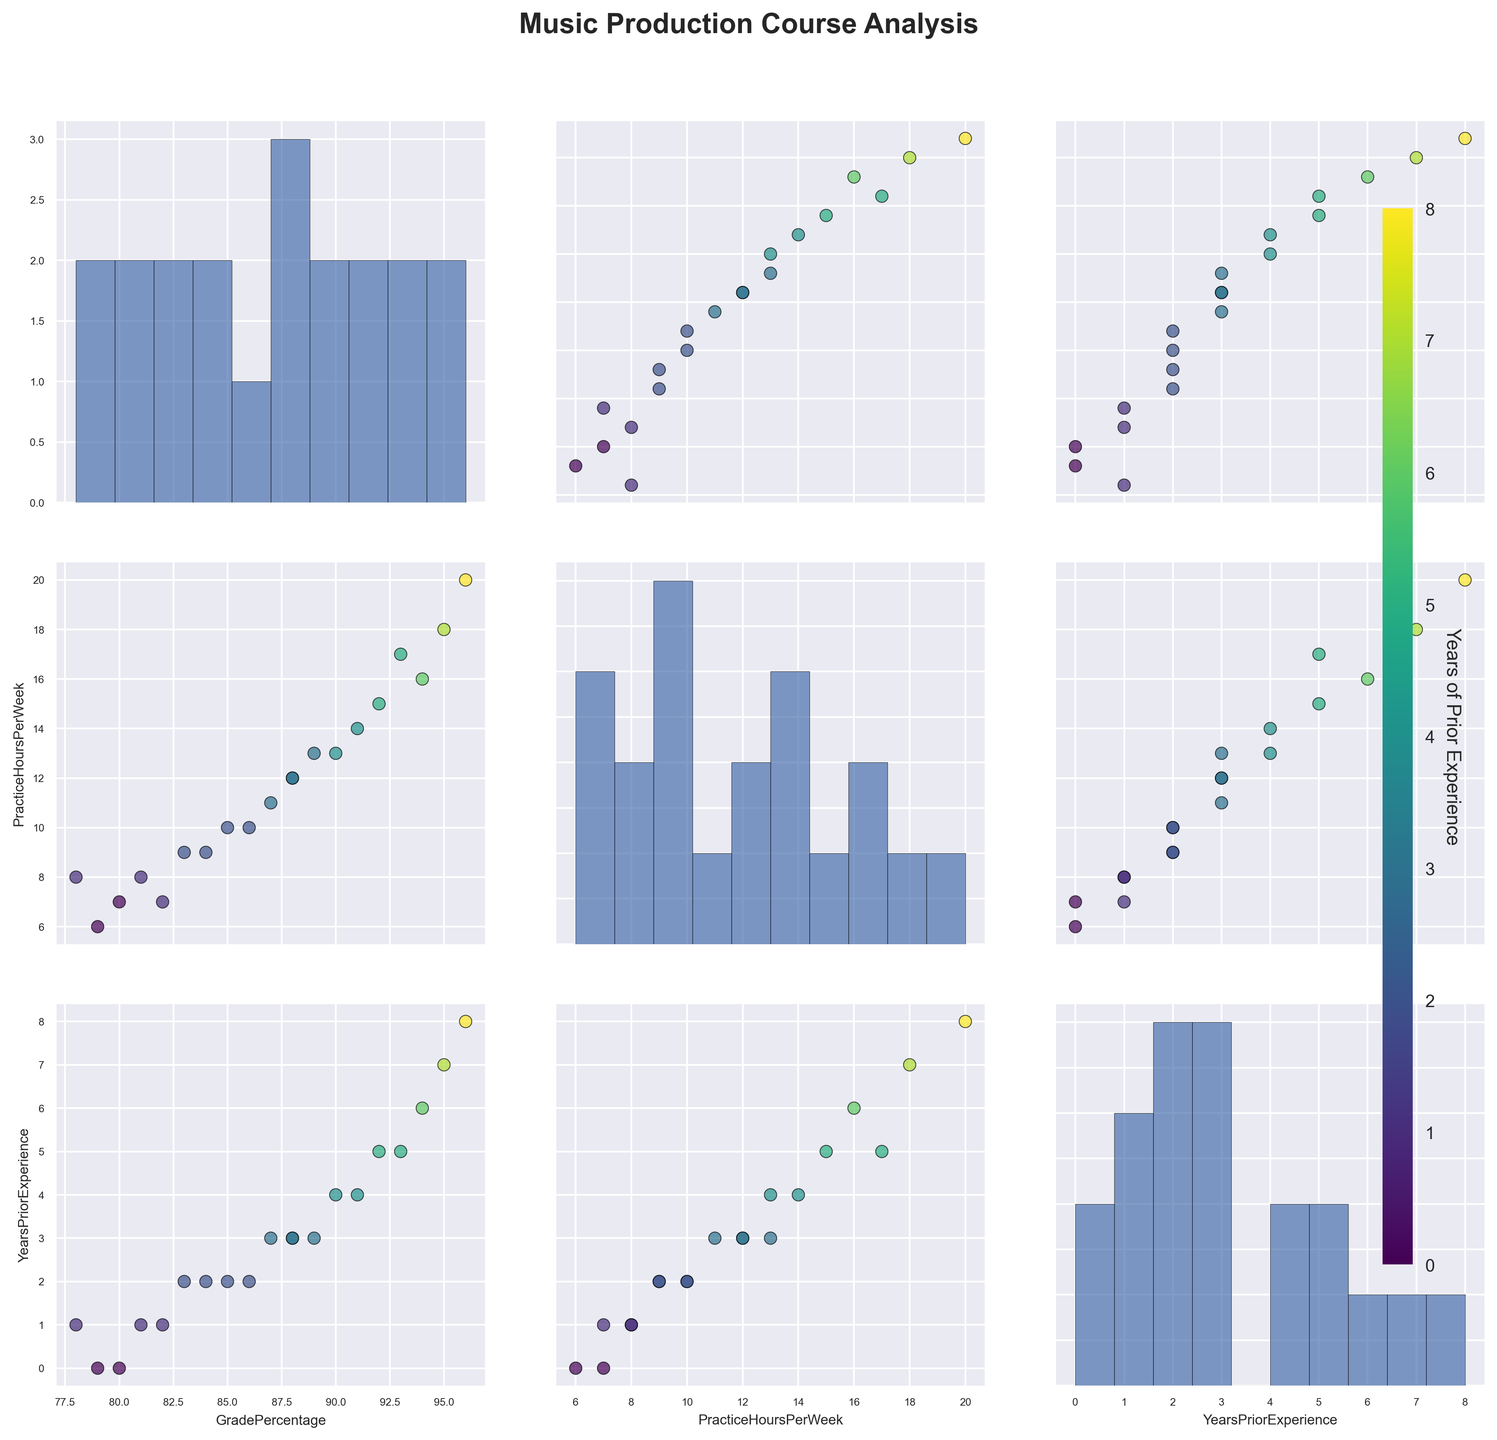What is the title of the figure? The title is usually positioned at the top of the figure to describe its overall content.
Answer: Music Production Course Analysis How many variables are being analyzed in this scatterplot matrix? Scatterplot matrices often analyze multiple variables and this one specifically has three distinct variables plotted against each other.
Answer: 3 Which variables have a strong positive correlation as seen in the scatterplots? By visually identifying scatterplots with tight clusters forming a line with positive slope, you can determine which variables are strongly positively correlated.
Answer: GradePercentage and PracticeHoursPerWeek What is the range of 'YearsPriorExperience' for the students? Checking the color bar on the right side of the figure, you can identify the minimum and maximum values associated with the color gradient.
Answer: 0 to 8 years Are there more students with high practice hours and high grades, or low practice hours and low grades? By observing the scatterplot between 'GradePercentage' and 'PracticeHoursPerWeek,' you can count the points at the higher and lower ends of both axes.
Answer: High practice hours and high grades How does 'YearsPriorExperience' impact 'GradePercentage'? By examining the scatter plots and their color intensities, you can see if higher years of prior experience correlate with higher grades.
Answer: More experience often correlates with higher grades Which variable shows the least variation in its histogram? By comparing the spread of the histograms along the diagonal, you can identify which variable has the narrowest distribution.
Answer: GradePercentage Is there any student who has zero years of prior experience and still scored high grades? By identifying points that are dark (indicating zero years of prior experience) in the scatterplot involving 'GradePercentage,' you can see their position on the y-axis.
Answer: No Which variable's histogram appears to be the most evenly distributed? By visually inspecting the histograms, determine which one has a relatively flat or evenly spread appearance.
Answer: PracticeHoursPerWeek Among students with high grades, do more students have high 'PracticeHoursPerWeek' or high 'YearsPriorExperience'? Examine the scatterplots involving 'GradePercentage' against 'PracticeHoursPerWeek' and 'GradePercentage' against 'YearsPriorExperience' and observe the concentration of high-scoring points.
Answer: High PracticeHoursPerWeek 